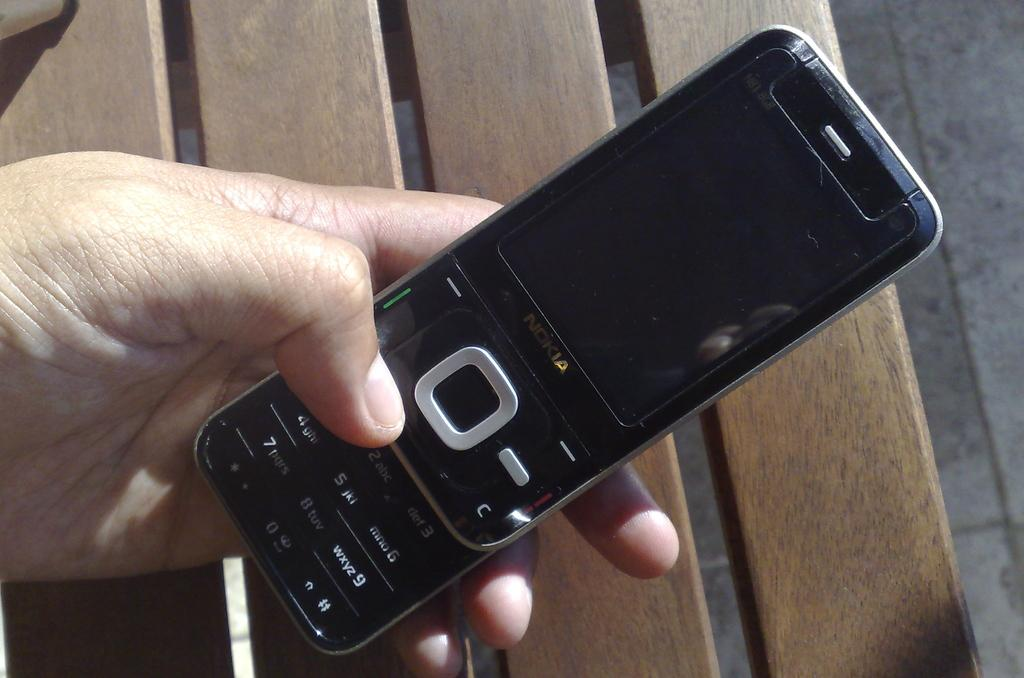Provide a one-sentence caption for the provided image. a nokia phone in someone's hand in the sunlight outdoors. 